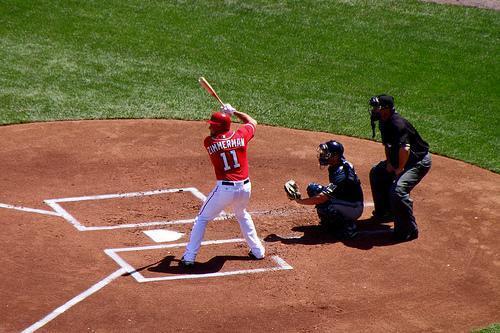How many men are shown?
Give a very brief answer. 3. 